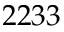Convert formula to latex. <formula><loc_0><loc_0><loc_500><loc_500>2 2 3 3</formula> 